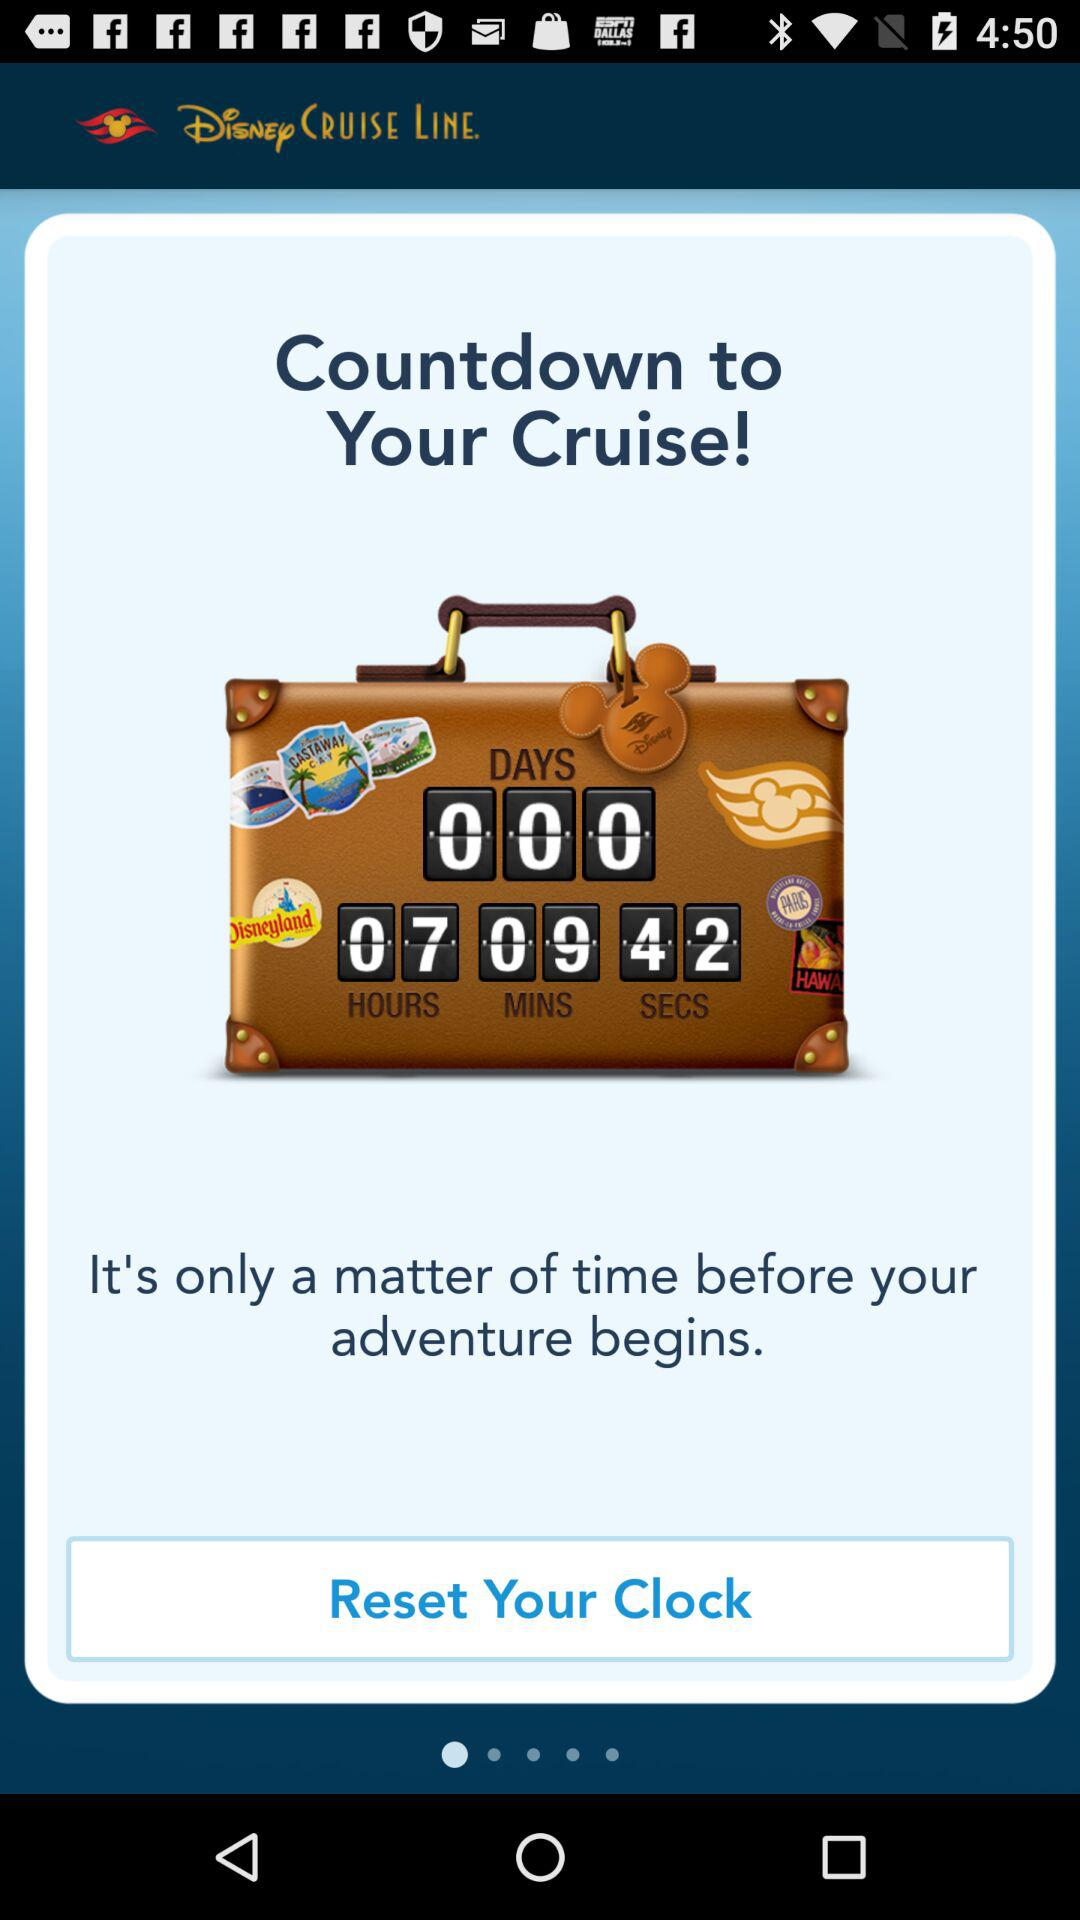How many days are left for the countdown to your cruise? The days left for the countdown to your cruise are "000". 